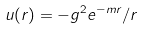<formula> <loc_0><loc_0><loc_500><loc_500>u ( r ) = - g ^ { 2 } e ^ { - m r } / r</formula> 